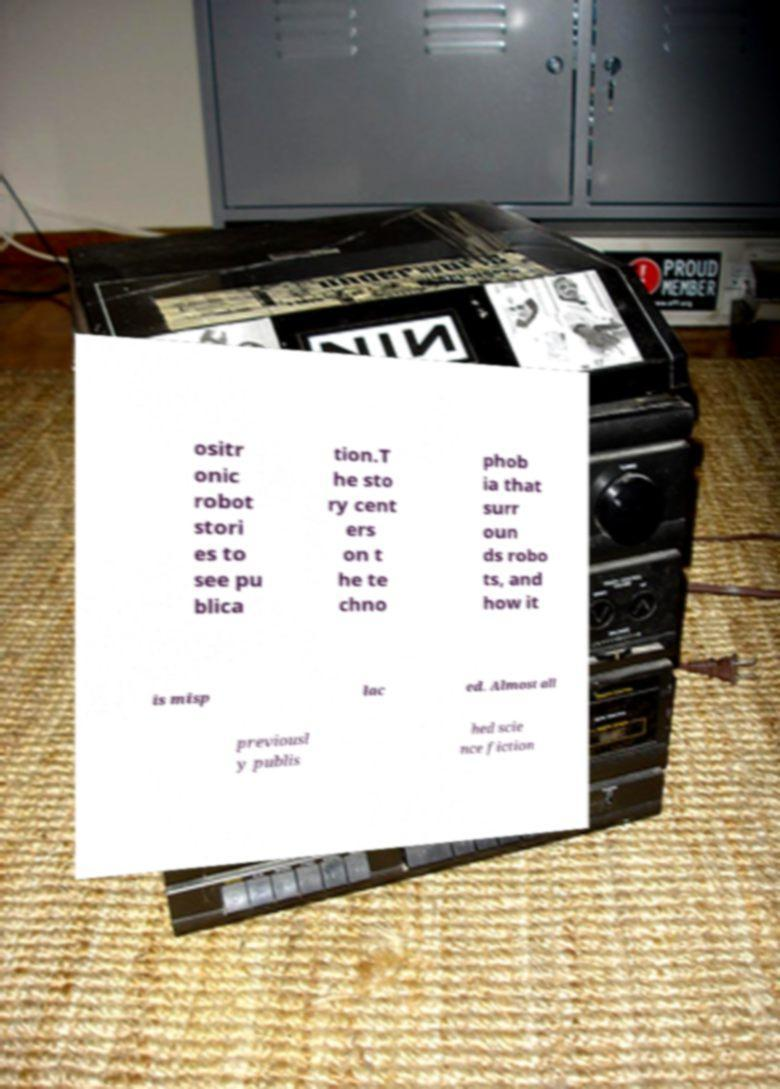Could you assist in decoding the text presented in this image and type it out clearly? ositr onic robot stori es to see pu blica tion.T he sto ry cent ers on t he te chno phob ia that surr oun ds robo ts, and how it is misp lac ed. Almost all previousl y publis hed scie nce fiction 